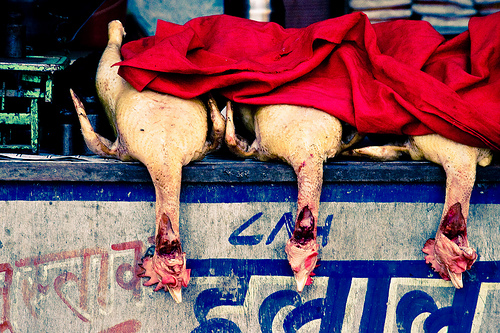<image>
Is there a dead chicken next to the dead chicken? Yes. The dead chicken is positioned adjacent to the dead chicken, located nearby in the same general area. 